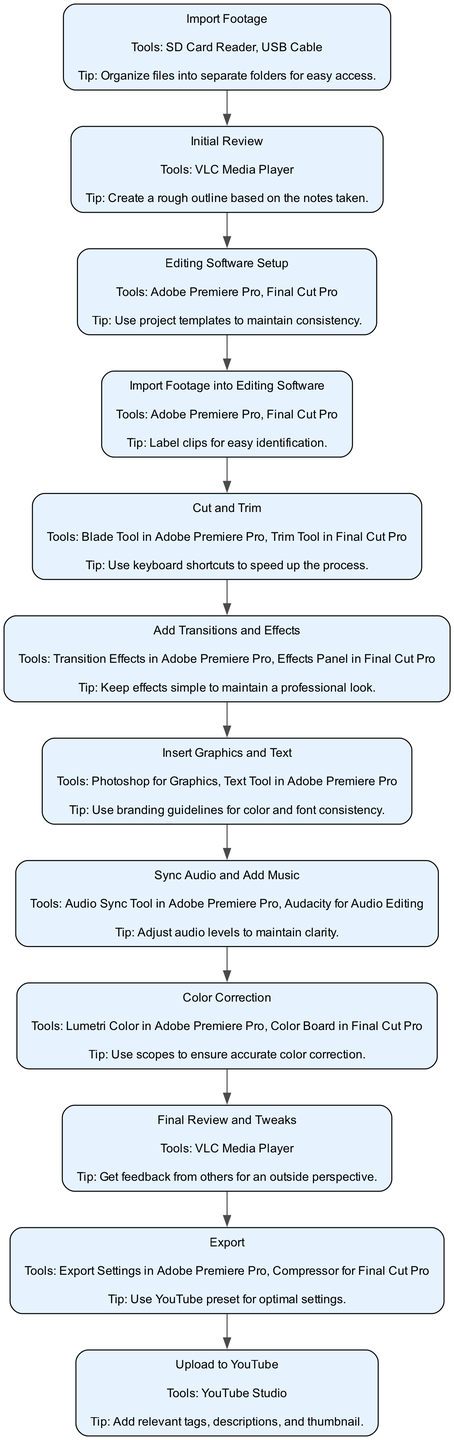What is the first step in the editing workflow? The first step, as shown in the diagram, is "Import Footage". It is the initial action required in the workflow, indicating where the process begins.
Answer: Import Footage How many tools are used in the "Color Correction" step? In the "Color Correction" step, there are two tools listed: "Lumetri Color in Adobe Premiere Pro" and "Color Board in Final Cut Pro". Thus, by counting, we get two tools.
Answer: 2 What is the last step in the process? The last step in the diagram is "Upload to YouTube". It appears at the end of the workflow, completing the editing and publication process.
Answer: Upload to YouTube Which tool is recommended for audio syncing? The diagram specifies the "Audio Sync Tool in Adobe Premiere Pro" as the tool to sync audio, indicating the preferred option for this task within the workflow.
Answer: Audio Sync Tool in Adobe Premiere Pro What action follows "Insert Graphics and Text"? Following the "Insert Graphics and Text" step in the flowchart, the next action is "Sync Audio and Add Music". This indicates a sequential transition from graphics insertion to audio synchronization.
Answer: Sync Audio and Add Music How many steps are in the total editing workflow? By counting the nodes in the diagram, we see there are a total of eleven steps outlined in the editing workflow for the darts game review video.
Answer: 11 What is a key tip for the "Cut and Trim" step? The key tip for the "Cut and Trim" step, as outlined in the diagram, is "Use keyboard shortcuts to speed up the process", emphasizing efficiency in performing edits.
Answer: Use keyboard shortcuts to speed up the process Which step comes directly after the "Editing Software Setup"? Directly after the "Editing Software Setup" step, the next step in the workflow is "Import Footage into Editing Software". This establishes a clear sequence of operations following software setup.
Answer: Import Footage into Editing Software What tool is suggested for exporting the final video? The diagram suggests using "Export Settings in Adobe Premiere Pro" for exporting the final video, indicating the designated tool for this operation in the workflow.
Answer: Export Settings in Adobe Premiere Pro 